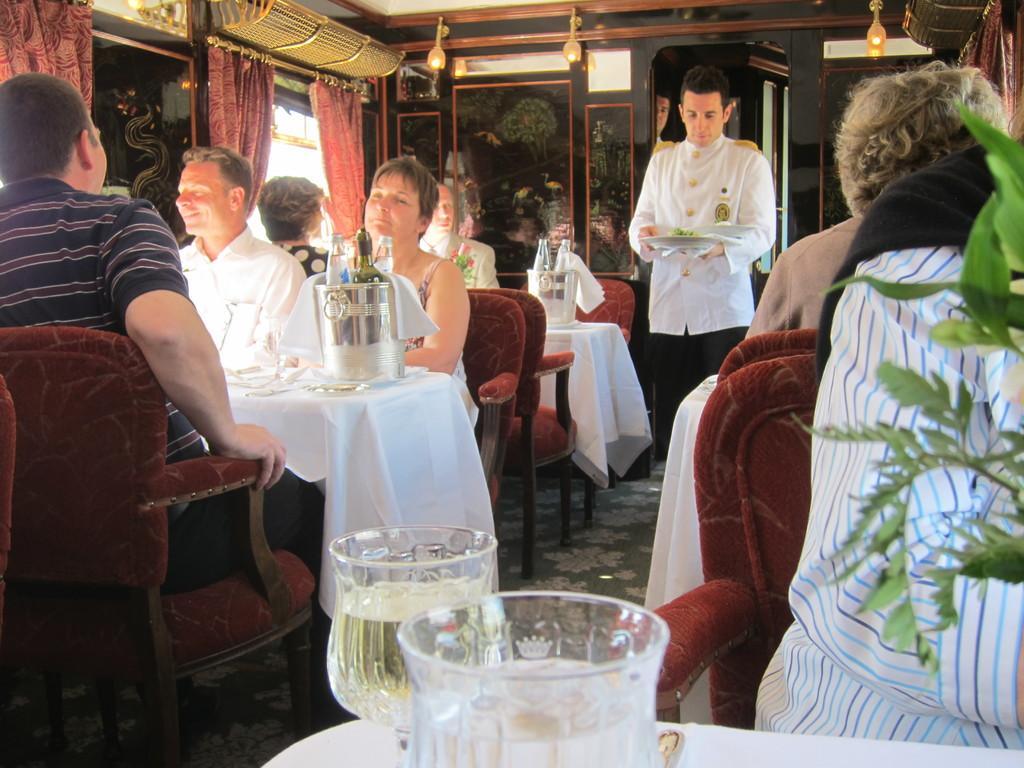Can you describe this image briefly? In this picture I can see glasses of wine and bottles in the buckets on the tables, there are flower vases on the tables, there are group of people sitting on the chairs, there is a person standing and holding a plate with bowls on it, there are curtains, windows, lights, window shutters and some other items. 